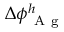Convert formula to latex. <formula><loc_0><loc_0><loc_500><loc_500>\Delta \phi _ { A g } ^ { h }</formula> 